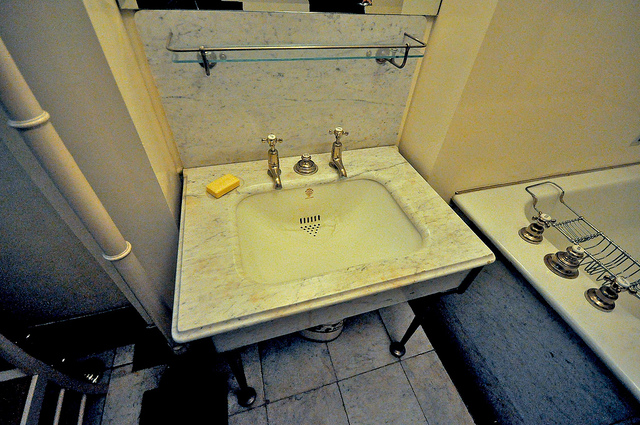Can you discuss the importance of the pipe next to the sink? Yes. The vertical pipe next to the sink is likely part of the plumbing system. It probably serves as a conduit for draining used water from the sink, directing it to the sewage or wastewater system. Efficient drainage is crucial for preventing water accumulation, which could lead to damage or mold growth. 